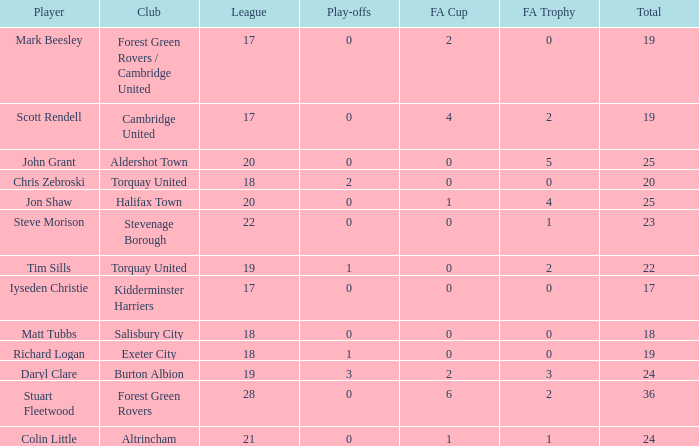Which of the lowest FA Trophys involved the Forest Green Rovers club when the play-offs number was bigger than 0? None. 